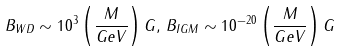Convert formula to latex. <formula><loc_0><loc_0><loc_500><loc_500>B _ { W D } \sim 1 0 ^ { 3 } \left ( \frac { M } { G e V } \right ) G , \, B _ { I G M } \sim 1 0 ^ { - 2 0 } \left ( \frac { M } { G e V } \right ) G</formula> 